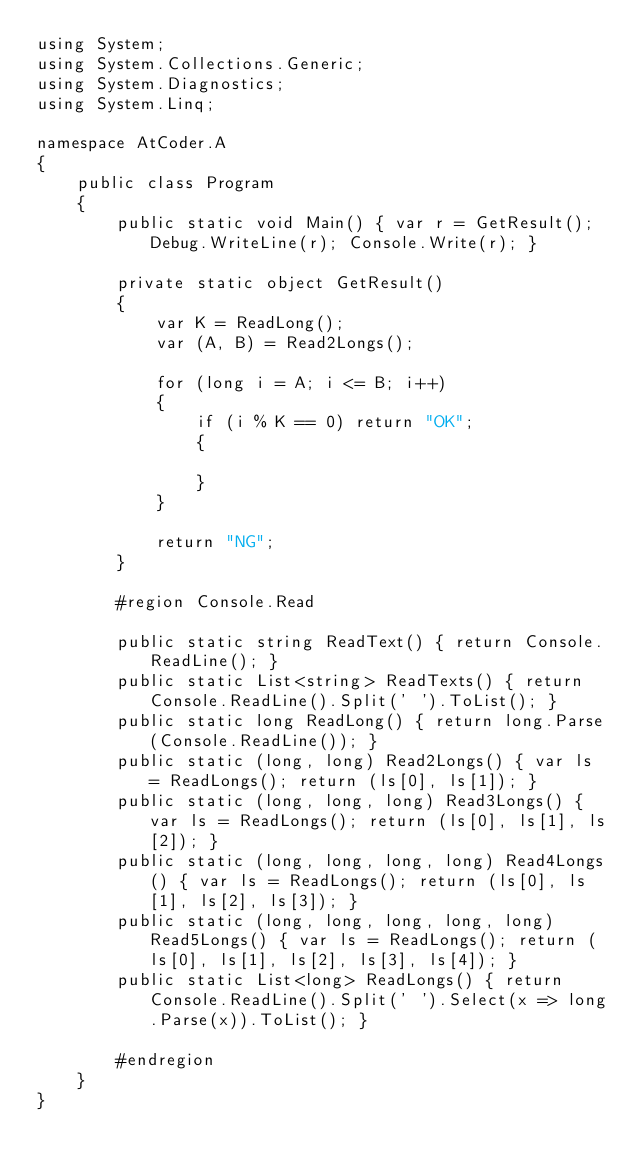<code> <loc_0><loc_0><loc_500><loc_500><_C#_>using System;
using System.Collections.Generic;
using System.Diagnostics;
using System.Linq;

namespace AtCoder.A
{
    public class Program
    {
        public static void Main() { var r = GetResult(); Debug.WriteLine(r); Console.Write(r); }

        private static object GetResult()
        {
            var K = ReadLong();
            var (A, B) = Read2Longs();

            for (long i = A; i <= B; i++)
            {
                if (i % K == 0) return "OK";
                {

                }
            }

            return "NG";
        }

        #region Console.Read

        public static string ReadText() { return Console.ReadLine(); }
        public static List<string> ReadTexts() { return Console.ReadLine().Split(' ').ToList(); }
        public static long ReadLong() { return long.Parse(Console.ReadLine()); }
        public static (long, long) Read2Longs() { var ls = ReadLongs(); return (ls[0], ls[1]); }
        public static (long, long, long) Read3Longs() { var ls = ReadLongs(); return (ls[0], ls[1], ls[2]); }
        public static (long, long, long, long) Read4Longs() { var ls = ReadLongs(); return (ls[0], ls[1], ls[2], ls[3]); }
        public static (long, long, long, long, long) Read5Longs() { var ls = ReadLongs(); return (ls[0], ls[1], ls[2], ls[3], ls[4]); }
        public static List<long> ReadLongs() { return Console.ReadLine().Split(' ').Select(x => long.Parse(x)).ToList(); }

        #endregion
    }
}
</code> 